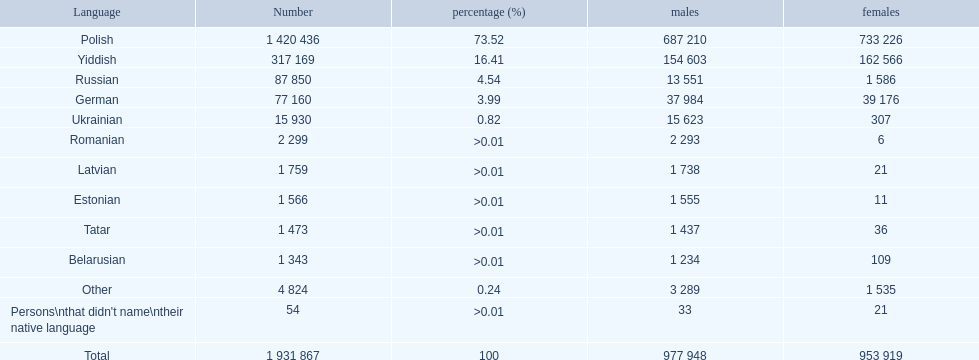What is the proportion of polish speakers? 73.52. What is the subsequent highest proportion of speakers? 16.41. Which language does this proportion represent? Yiddish. 